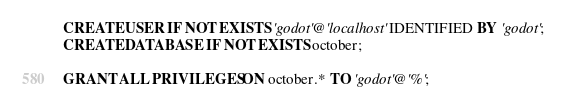<code> <loc_0><loc_0><loc_500><loc_500><_SQL_>CREATE USER IF NOT EXISTS 'godot'@'localhost' IDENTIFIED BY 'godot';
CREATE DATABASE IF NOT EXISTS october;

GRANT ALL PRIVILEGES ON october.* TO 'godot'@'%';
</code> 